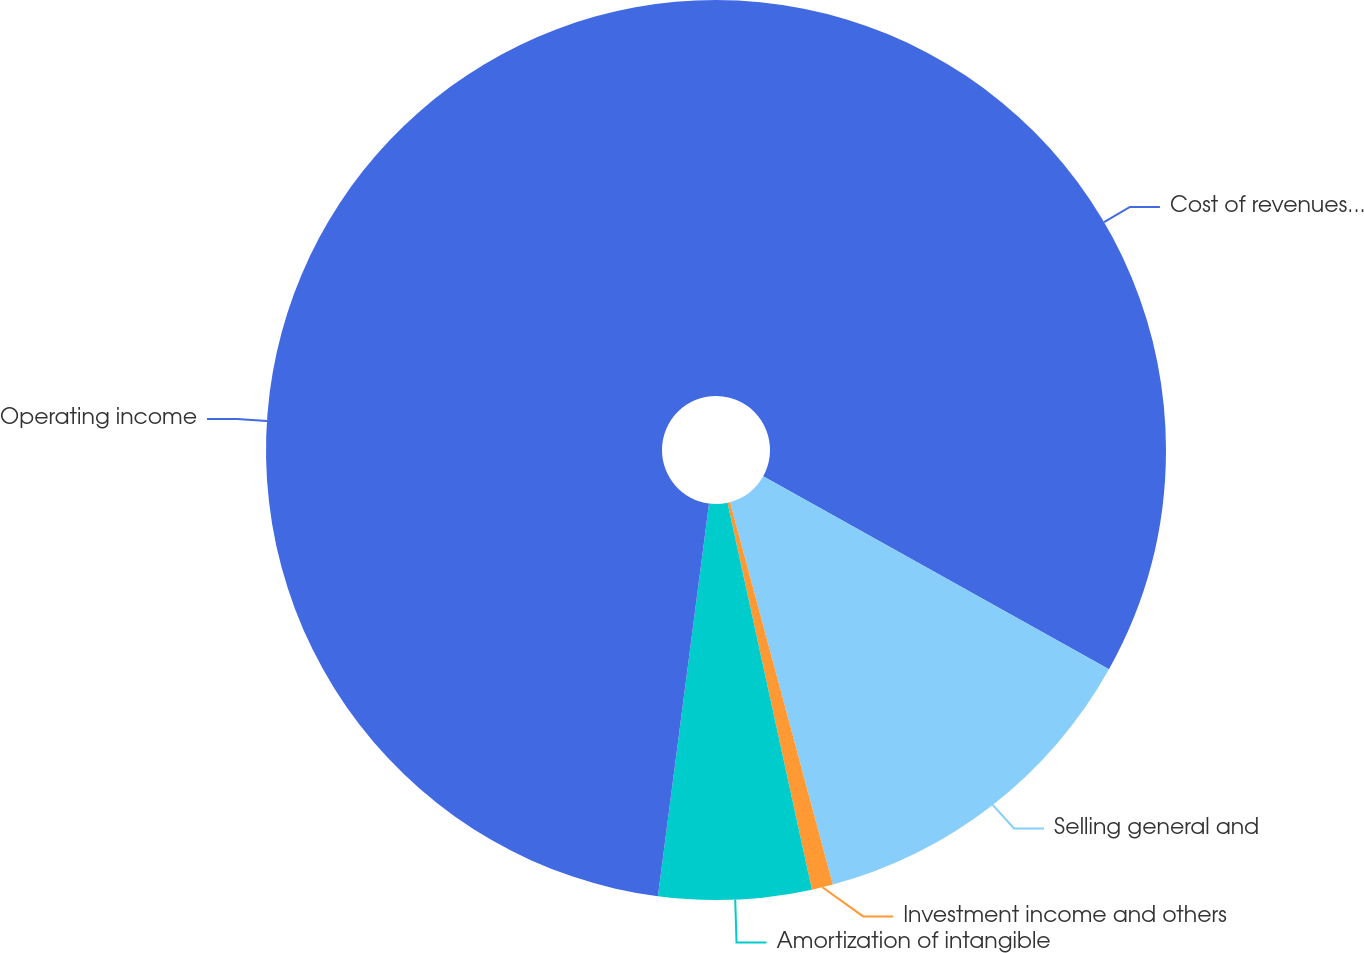<chart> <loc_0><loc_0><loc_500><loc_500><pie_chart><fcel>Cost of revenues (exclusive of<fcel>Selling general and<fcel>Investment income and others<fcel>Amortization of intangible<fcel>Operating income<nl><fcel>33.1%<fcel>12.72%<fcel>0.76%<fcel>5.48%<fcel>47.94%<nl></chart> 